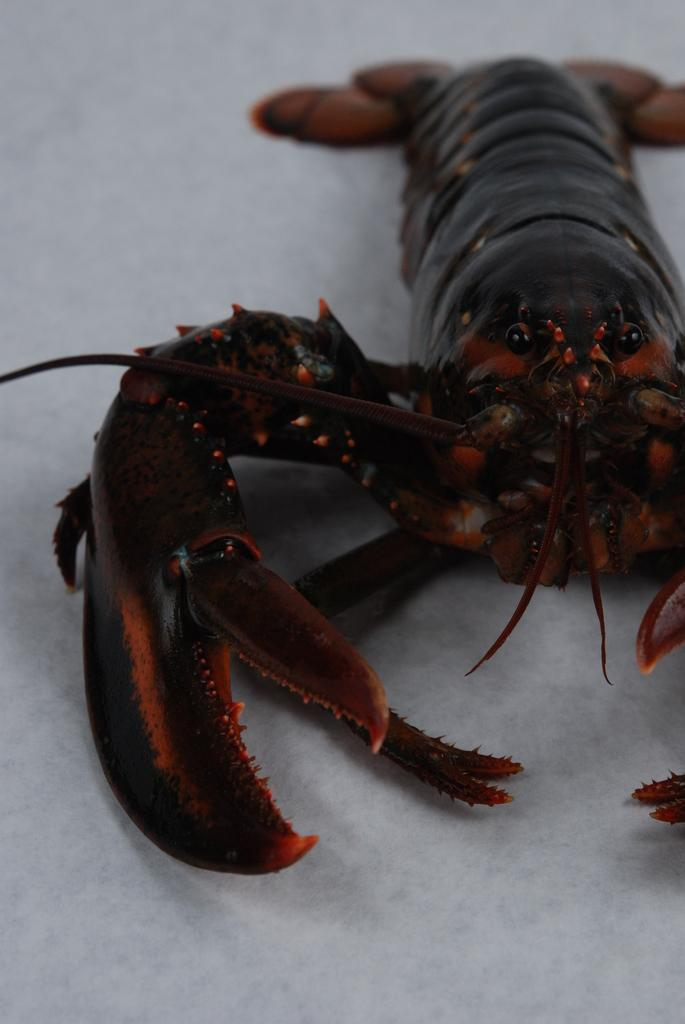What type of sea creature is in the picture? There is an American lobster in the picture. What colors can be seen on the American lobster? The American lobster has brown and black coloring. What color is the background of the image? The background of the image is white. What is the purpose of the passenger in the image? There is no passenger present in the image; it features an American lobster. How does the nerve affect the appearance of the American lobster in the image? There is no mention of a nerve in the image, and it does not affect the appearance of the American lobster. 